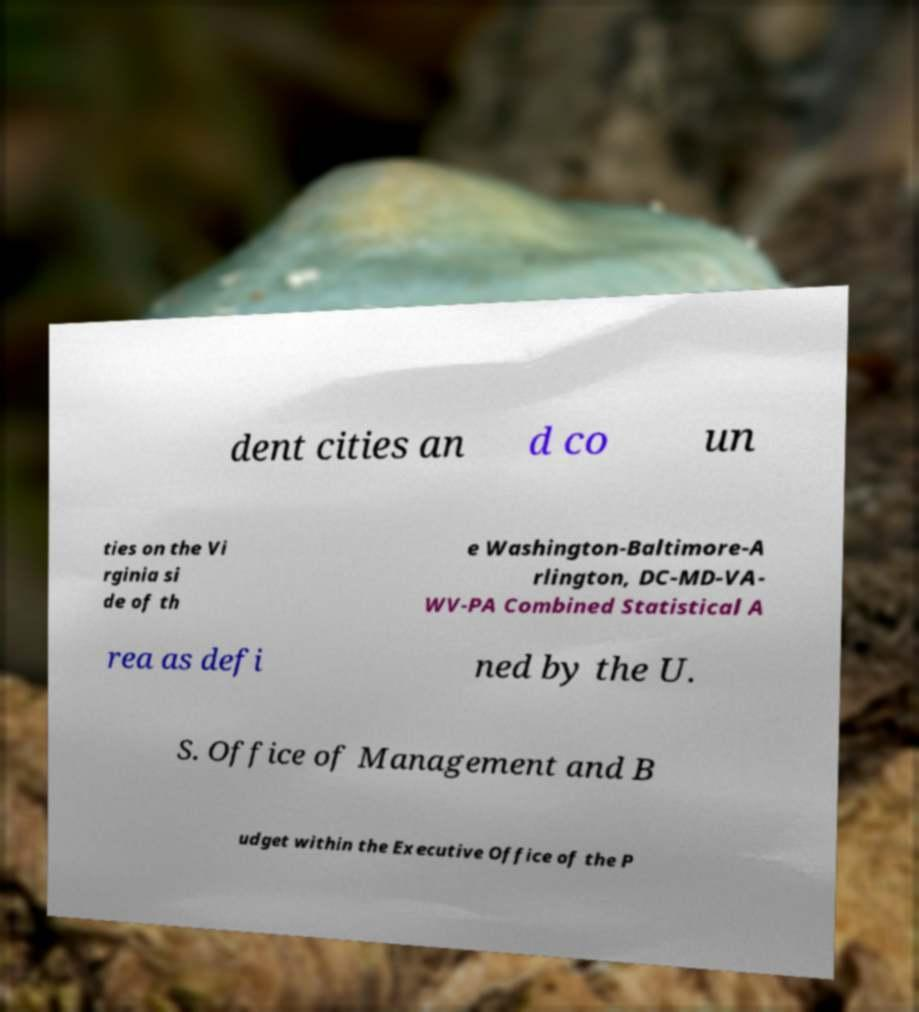Can you accurately transcribe the text from the provided image for me? dent cities an d co un ties on the Vi rginia si de of th e Washington-Baltimore-A rlington, DC-MD-VA- WV-PA Combined Statistical A rea as defi ned by the U. S. Office of Management and B udget within the Executive Office of the P 